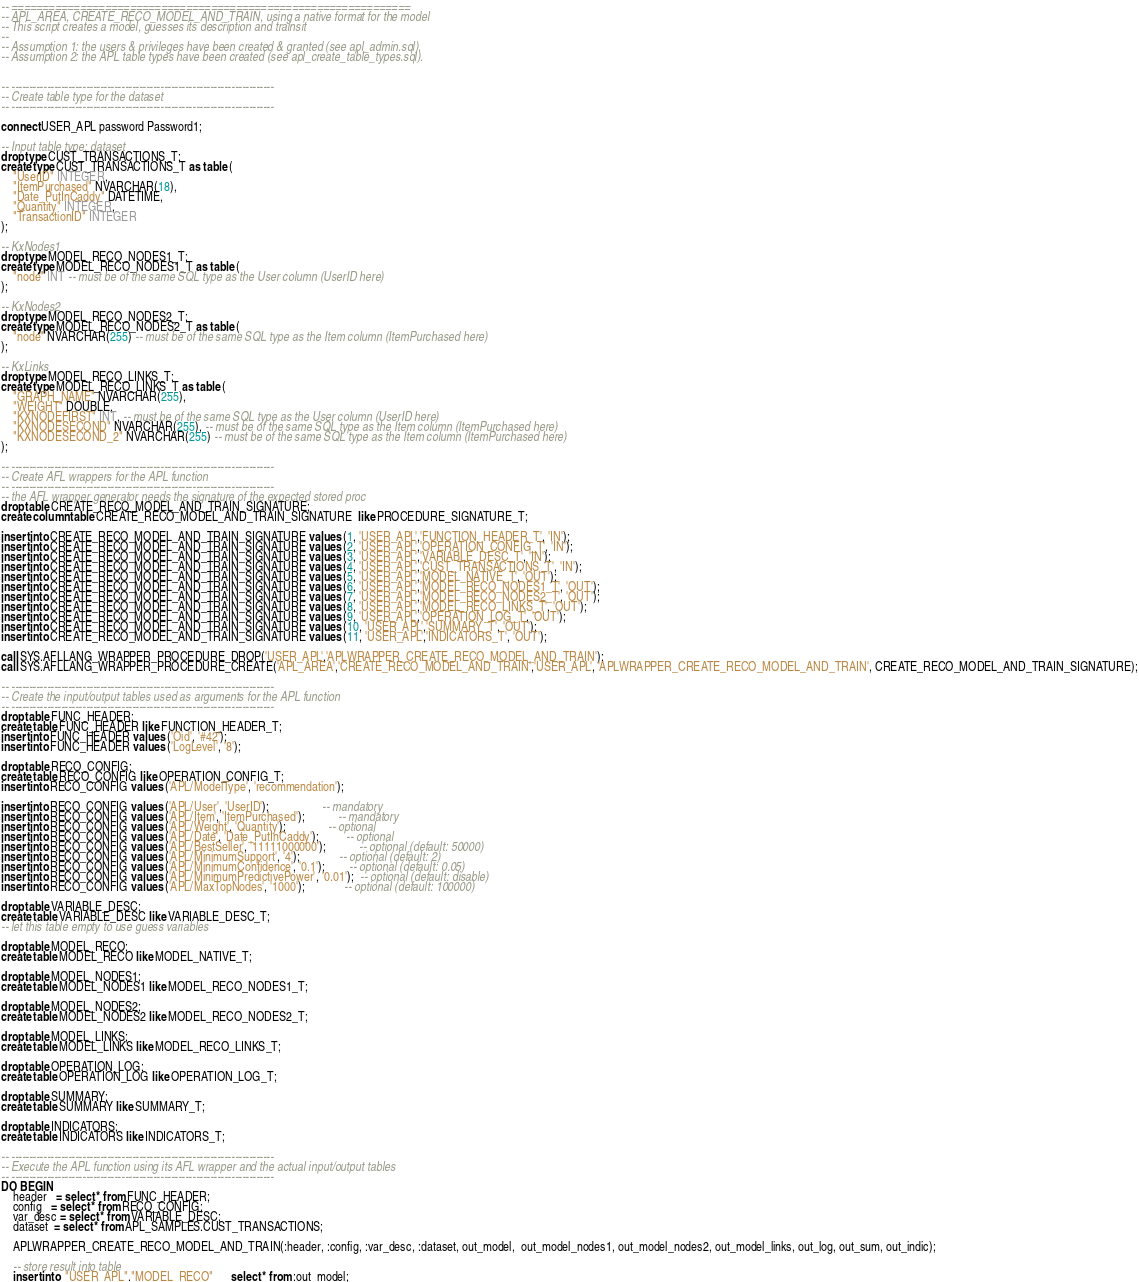Convert code to text. <code><loc_0><loc_0><loc_500><loc_500><_SQL_>-- ================================================================
-- APL_AREA, CREATE_RECO_MODEL_AND_TRAIN, using a native format for the model
-- This script creates a model, guesses its description and trainsit
--
-- Assumption 1: the users & privileges have been created & granted (see apl_admin.sql).
-- Assumption 2: the APL table types have been created (see apl_create_table_types.sql).


-- --------------------------------------------------------------------------
-- Create table type for the dataset
-- --------------------------------------------------------------------------

connect USER_APL password Password1;

-- Input table type: dataset
drop type CUST_TRANSACTIONS_T;
create type CUST_TRANSACTIONS_T as table (
    "UserID" INTEGER,
    "ItemPurchased" NVARCHAR(18),
    "Date_PutInCaddy" DATETIME,
    "Quantity" INTEGER,
    "TransactionID" INTEGER
);

-- KxNodes1  
drop type MODEL_RECO_NODES1_T;
create type MODEL_RECO_NODES1_T as table (
	"node" INT -- must be of the same SQL type as the User column (UserID here)
);

-- KxNodes2 
drop type MODEL_RECO_NODES2_T;
create type MODEL_RECO_NODES2_T as table (
	"node" NVARCHAR(255) -- must be of the same SQL type as the Item column (ItemPurchased here)
);

-- KxLinks
drop type MODEL_RECO_LINKS_T;
create type MODEL_RECO_LINKS_T as table (
    "GRAPH_NAME" NVARCHAR(255),
    "WEIGHT" DOUBLE,
    "KXNODEFIRST" INT, -- must be of the same SQL type as the User column (UserID here)
    "KXNODESECOND" NVARCHAR(255), -- must be of the same SQL type as the Item column (ItemPurchased here)
    "KXNODESECOND_2" NVARCHAR(255) -- must be of the same SQL type as the Item column (ItemPurchased here)
);
  
-- --------------------------------------------------------------------------
-- Create AFL wrappers for the APL function
-- --------------------------------------------------------------------------
-- the AFL wrapper generator needs the signature of the expected stored proc
drop table CREATE_RECO_MODEL_AND_TRAIN_SIGNATURE;
create column table CREATE_RECO_MODEL_AND_TRAIN_SIGNATURE  like PROCEDURE_SIGNATURE_T;

insert into CREATE_RECO_MODEL_AND_TRAIN_SIGNATURE values (1, 'USER_APL','FUNCTION_HEADER_T', 'IN');
insert into CREATE_RECO_MODEL_AND_TRAIN_SIGNATURE values (2, 'USER_APL','OPERATION_CONFIG_T', 'IN');
insert into CREATE_RECO_MODEL_AND_TRAIN_SIGNATURE values (3, 'USER_APL','VARIABLE_DESC_T', 'IN');
insert into CREATE_RECO_MODEL_AND_TRAIN_SIGNATURE values (4, 'USER_APL','CUST_TRANSACTIONS_T', 'IN');
insert into CREATE_RECO_MODEL_AND_TRAIN_SIGNATURE values (5, 'USER_APL','MODEL_NATIVE_T', 'OUT');
insert into CREATE_RECO_MODEL_AND_TRAIN_SIGNATURE values (6, 'USER_APL','MODEL_RECO_NODES1_T', 'OUT');
insert into CREATE_RECO_MODEL_AND_TRAIN_SIGNATURE values (7, 'USER_APL','MODEL_RECO_NODES2_T', 'OUT');
insert into CREATE_RECO_MODEL_AND_TRAIN_SIGNATURE values (8, 'USER_APL','MODEL_RECO_LINKS_T', 'OUT');
insert into CREATE_RECO_MODEL_AND_TRAIN_SIGNATURE values (9, 'USER_APL','OPERATION_LOG_T', 'OUT');
insert into CREATE_RECO_MODEL_AND_TRAIN_SIGNATURE values (10, 'USER_APL','SUMMARY_T', 'OUT');
insert into CREATE_RECO_MODEL_AND_TRAIN_SIGNATURE values (11, 'USER_APL','INDICATORS_T', 'OUT');

call SYS.AFLLANG_WRAPPER_PROCEDURE_DROP('USER_APL','APLWRAPPER_CREATE_RECO_MODEL_AND_TRAIN');
call SYS.AFLLANG_WRAPPER_PROCEDURE_CREATE('APL_AREA','CREATE_RECO_MODEL_AND_TRAIN','USER_APL', 'APLWRAPPER_CREATE_RECO_MODEL_AND_TRAIN', CREATE_RECO_MODEL_AND_TRAIN_SIGNATURE);

-- --------------------------------------------------------------------------
-- Create the input/output tables used as arguments for the APL function
-- --------------------------------------------------------------------------
drop table FUNC_HEADER;
create table FUNC_HEADER like FUNCTION_HEADER_T;
insert into FUNC_HEADER values ('Oid', '#42');
insert into FUNC_HEADER values ('LogLevel', '8');

drop table RECO_CONFIG;
create table RECO_CONFIG like OPERATION_CONFIG_T;
insert into RECO_CONFIG values ('APL/ModelType', 'recommendation');

insert into RECO_CONFIG values ('APL/User', 'UserID');                  -- mandatory
insert into RECO_CONFIG values ('APL/Item', 'ItemPurchased');           -- mandatory
insert into RECO_CONFIG values ('APL/Weight', 'Quantity');              -- optional
insert into RECO_CONFIG values ('APL/Date', 'Date_PutInCaddy');         -- optional
insert into RECO_CONFIG values ('APL/BestSeller', '11111000000');           -- optional (default: 50000)
insert into RECO_CONFIG values ('APL/MinimumSupport', '4');             -- optional (default: 2)
insert into RECO_CONFIG values ('APL/MinimumConfidence', '0.1');        -- optional (default: 0.05)
insert into RECO_CONFIG values ('APL/MinimumPredictivePower', '0.01');  -- optional (default: disable)
insert into RECO_CONFIG values ('APL/MaxTopNodes', '1000');             -- optional (default: 100000)

drop table VARIABLE_DESC;
create table VARIABLE_DESC like VARIABLE_DESC_T;
-- let this table empty to use guess variables

drop table MODEL_RECO;
create table MODEL_RECO like MODEL_NATIVE_T;

drop table MODEL_NODES1;
create table MODEL_NODES1 like MODEL_RECO_NODES1_T;

drop table MODEL_NODES2;
create table MODEL_NODES2 like MODEL_RECO_NODES2_T;

drop table MODEL_LINKS;
create table MODEL_LINKS like MODEL_RECO_LINKS_T;

drop table OPERATION_LOG;
create table OPERATION_LOG like OPERATION_LOG_T;

drop table SUMMARY;
create table SUMMARY like SUMMARY_T;

drop table INDICATORS;
create table INDICATORS like INDICATORS_T;

-- --------------------------------------------------------------------------
-- Execute the APL function using its AFL wrapper and the actual input/output tables
-- --------------------------------------------------------------------------
DO BEGIN     
    header   = select * from FUNC_HEADER;             
    config   = select * from RECO_CONFIG;            
    var_desc = select * from VARIABLE_DESC;              
    dataset  = select * from APL_SAMPLES.CUST_TRANSACTIONS;  

    APLWRAPPER_CREATE_RECO_MODEL_AND_TRAIN(:header, :config, :var_desc, :dataset, out_model,  out_model_nodes1, out_model_nodes2, out_model_links, out_log, out_sum, out_indic);          

    -- store result into table
    insert into  "USER_APL"."MODEL_RECO"      select * from :out_model;</code> 